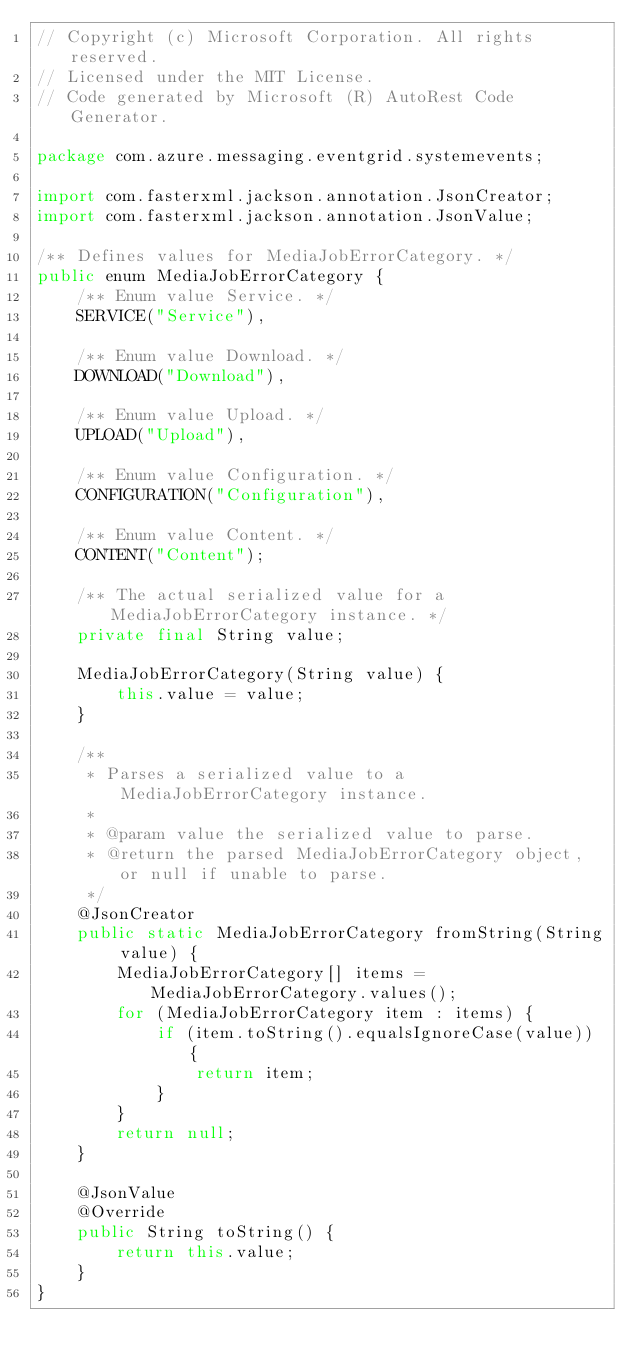Convert code to text. <code><loc_0><loc_0><loc_500><loc_500><_Java_>// Copyright (c) Microsoft Corporation. All rights reserved.
// Licensed under the MIT License.
// Code generated by Microsoft (R) AutoRest Code Generator.

package com.azure.messaging.eventgrid.systemevents;

import com.fasterxml.jackson.annotation.JsonCreator;
import com.fasterxml.jackson.annotation.JsonValue;

/** Defines values for MediaJobErrorCategory. */
public enum MediaJobErrorCategory {
    /** Enum value Service. */
    SERVICE("Service"),

    /** Enum value Download. */
    DOWNLOAD("Download"),

    /** Enum value Upload. */
    UPLOAD("Upload"),

    /** Enum value Configuration. */
    CONFIGURATION("Configuration"),

    /** Enum value Content. */
    CONTENT("Content");

    /** The actual serialized value for a MediaJobErrorCategory instance. */
    private final String value;

    MediaJobErrorCategory(String value) {
        this.value = value;
    }

    /**
     * Parses a serialized value to a MediaJobErrorCategory instance.
     *
     * @param value the serialized value to parse.
     * @return the parsed MediaJobErrorCategory object, or null if unable to parse.
     */
    @JsonCreator
    public static MediaJobErrorCategory fromString(String value) {
        MediaJobErrorCategory[] items = MediaJobErrorCategory.values();
        for (MediaJobErrorCategory item : items) {
            if (item.toString().equalsIgnoreCase(value)) {
                return item;
            }
        }
        return null;
    }

    @JsonValue
    @Override
    public String toString() {
        return this.value;
    }
}
</code> 